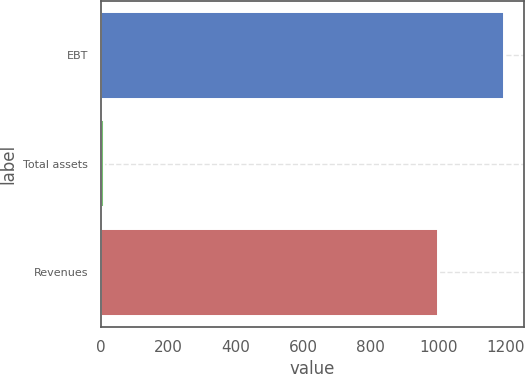<chart> <loc_0><loc_0><loc_500><loc_500><bar_chart><fcel>EBT<fcel>Total assets<fcel>Revenues<nl><fcel>1195<fcel>8<fcel>1000<nl></chart> 